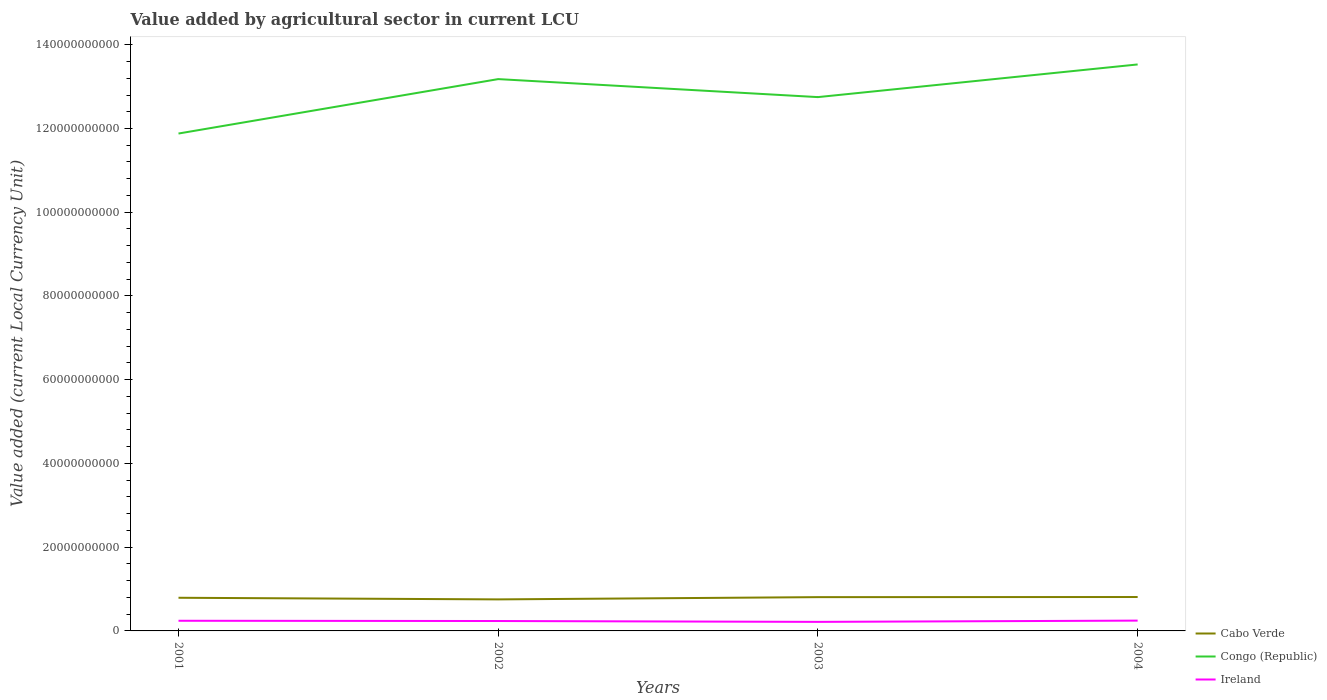How many different coloured lines are there?
Ensure brevity in your answer.  3. Is the number of lines equal to the number of legend labels?
Your answer should be very brief. Yes. Across all years, what is the maximum value added by agricultural sector in Ireland?
Offer a very short reply. 2.16e+09. What is the total value added by agricultural sector in Cabo Verde in the graph?
Your answer should be very brief. -2.96e+07. What is the difference between the highest and the second highest value added by agricultural sector in Cabo Verde?
Your response must be concise. 5.65e+08. What is the difference between the highest and the lowest value added by agricultural sector in Ireland?
Provide a short and direct response. 3. How many years are there in the graph?
Provide a succinct answer. 4. How many legend labels are there?
Offer a very short reply. 3. What is the title of the graph?
Keep it short and to the point. Value added by agricultural sector in current LCU. Does "Colombia" appear as one of the legend labels in the graph?
Offer a very short reply. No. What is the label or title of the X-axis?
Offer a very short reply. Years. What is the label or title of the Y-axis?
Your response must be concise. Value added (current Local Currency Unit). What is the Value added (current Local Currency Unit) of Cabo Verde in 2001?
Your response must be concise. 7.92e+09. What is the Value added (current Local Currency Unit) in Congo (Republic) in 2001?
Your answer should be compact. 1.19e+11. What is the Value added (current Local Currency Unit) in Ireland in 2001?
Keep it short and to the point. 2.43e+09. What is the Value added (current Local Currency Unit) in Cabo Verde in 2002?
Provide a short and direct response. 7.53e+09. What is the Value added (current Local Currency Unit) of Congo (Republic) in 2002?
Give a very brief answer. 1.32e+11. What is the Value added (current Local Currency Unit) in Ireland in 2002?
Give a very brief answer. 2.37e+09. What is the Value added (current Local Currency Unit) of Cabo Verde in 2003?
Provide a succinct answer. 8.07e+09. What is the Value added (current Local Currency Unit) in Congo (Republic) in 2003?
Give a very brief answer. 1.28e+11. What is the Value added (current Local Currency Unit) of Ireland in 2003?
Offer a terse response. 2.16e+09. What is the Value added (current Local Currency Unit) of Cabo Verde in 2004?
Keep it short and to the point. 8.10e+09. What is the Value added (current Local Currency Unit) of Congo (Republic) in 2004?
Make the answer very short. 1.35e+11. What is the Value added (current Local Currency Unit) of Ireland in 2004?
Ensure brevity in your answer.  2.46e+09. Across all years, what is the maximum Value added (current Local Currency Unit) of Cabo Verde?
Your response must be concise. 8.10e+09. Across all years, what is the maximum Value added (current Local Currency Unit) in Congo (Republic)?
Provide a succinct answer. 1.35e+11. Across all years, what is the maximum Value added (current Local Currency Unit) in Ireland?
Provide a short and direct response. 2.46e+09. Across all years, what is the minimum Value added (current Local Currency Unit) of Cabo Verde?
Make the answer very short. 7.53e+09. Across all years, what is the minimum Value added (current Local Currency Unit) of Congo (Republic)?
Your response must be concise. 1.19e+11. Across all years, what is the minimum Value added (current Local Currency Unit) of Ireland?
Offer a terse response. 2.16e+09. What is the total Value added (current Local Currency Unit) in Cabo Verde in the graph?
Ensure brevity in your answer.  3.16e+1. What is the total Value added (current Local Currency Unit) in Congo (Republic) in the graph?
Give a very brief answer. 5.13e+11. What is the total Value added (current Local Currency Unit) in Ireland in the graph?
Offer a very short reply. 9.42e+09. What is the difference between the Value added (current Local Currency Unit) in Cabo Verde in 2001 and that in 2002?
Give a very brief answer. 3.89e+08. What is the difference between the Value added (current Local Currency Unit) in Congo (Republic) in 2001 and that in 2002?
Keep it short and to the point. -1.30e+1. What is the difference between the Value added (current Local Currency Unit) in Ireland in 2001 and that in 2002?
Ensure brevity in your answer.  6.06e+07. What is the difference between the Value added (current Local Currency Unit) in Cabo Verde in 2001 and that in 2003?
Ensure brevity in your answer.  -1.47e+08. What is the difference between the Value added (current Local Currency Unit) in Congo (Republic) in 2001 and that in 2003?
Give a very brief answer. -8.70e+09. What is the difference between the Value added (current Local Currency Unit) in Ireland in 2001 and that in 2003?
Your answer should be very brief. 2.67e+08. What is the difference between the Value added (current Local Currency Unit) of Cabo Verde in 2001 and that in 2004?
Offer a very short reply. -1.76e+08. What is the difference between the Value added (current Local Currency Unit) in Congo (Republic) in 2001 and that in 2004?
Your response must be concise. -1.65e+1. What is the difference between the Value added (current Local Currency Unit) in Ireland in 2001 and that in 2004?
Make the answer very short. -3.66e+07. What is the difference between the Value added (current Local Currency Unit) in Cabo Verde in 2002 and that in 2003?
Offer a very short reply. -5.35e+08. What is the difference between the Value added (current Local Currency Unit) of Congo (Republic) in 2002 and that in 2003?
Your response must be concise. 4.30e+09. What is the difference between the Value added (current Local Currency Unit) of Ireland in 2002 and that in 2003?
Ensure brevity in your answer.  2.06e+08. What is the difference between the Value added (current Local Currency Unit) in Cabo Verde in 2002 and that in 2004?
Provide a succinct answer. -5.65e+08. What is the difference between the Value added (current Local Currency Unit) of Congo (Republic) in 2002 and that in 2004?
Your answer should be compact. -3.50e+09. What is the difference between the Value added (current Local Currency Unit) of Ireland in 2002 and that in 2004?
Offer a very short reply. -9.72e+07. What is the difference between the Value added (current Local Currency Unit) of Cabo Verde in 2003 and that in 2004?
Provide a short and direct response. -2.96e+07. What is the difference between the Value added (current Local Currency Unit) in Congo (Republic) in 2003 and that in 2004?
Your answer should be compact. -7.80e+09. What is the difference between the Value added (current Local Currency Unit) in Ireland in 2003 and that in 2004?
Your answer should be very brief. -3.03e+08. What is the difference between the Value added (current Local Currency Unit) in Cabo Verde in 2001 and the Value added (current Local Currency Unit) in Congo (Republic) in 2002?
Offer a terse response. -1.24e+11. What is the difference between the Value added (current Local Currency Unit) in Cabo Verde in 2001 and the Value added (current Local Currency Unit) in Ireland in 2002?
Your answer should be very brief. 5.55e+09. What is the difference between the Value added (current Local Currency Unit) in Congo (Republic) in 2001 and the Value added (current Local Currency Unit) in Ireland in 2002?
Your answer should be very brief. 1.16e+11. What is the difference between the Value added (current Local Currency Unit) of Cabo Verde in 2001 and the Value added (current Local Currency Unit) of Congo (Republic) in 2003?
Your response must be concise. -1.20e+11. What is the difference between the Value added (current Local Currency Unit) in Cabo Verde in 2001 and the Value added (current Local Currency Unit) in Ireland in 2003?
Your answer should be very brief. 5.76e+09. What is the difference between the Value added (current Local Currency Unit) in Congo (Republic) in 2001 and the Value added (current Local Currency Unit) in Ireland in 2003?
Offer a very short reply. 1.17e+11. What is the difference between the Value added (current Local Currency Unit) of Cabo Verde in 2001 and the Value added (current Local Currency Unit) of Congo (Republic) in 2004?
Your answer should be very brief. -1.27e+11. What is the difference between the Value added (current Local Currency Unit) in Cabo Verde in 2001 and the Value added (current Local Currency Unit) in Ireland in 2004?
Offer a very short reply. 5.46e+09. What is the difference between the Value added (current Local Currency Unit) of Congo (Republic) in 2001 and the Value added (current Local Currency Unit) of Ireland in 2004?
Your answer should be very brief. 1.16e+11. What is the difference between the Value added (current Local Currency Unit) in Cabo Verde in 2002 and the Value added (current Local Currency Unit) in Congo (Republic) in 2003?
Offer a very short reply. -1.20e+11. What is the difference between the Value added (current Local Currency Unit) in Cabo Verde in 2002 and the Value added (current Local Currency Unit) in Ireland in 2003?
Provide a short and direct response. 5.37e+09. What is the difference between the Value added (current Local Currency Unit) in Congo (Republic) in 2002 and the Value added (current Local Currency Unit) in Ireland in 2003?
Make the answer very short. 1.30e+11. What is the difference between the Value added (current Local Currency Unit) in Cabo Verde in 2002 and the Value added (current Local Currency Unit) in Congo (Republic) in 2004?
Make the answer very short. -1.28e+11. What is the difference between the Value added (current Local Currency Unit) in Cabo Verde in 2002 and the Value added (current Local Currency Unit) in Ireland in 2004?
Your answer should be very brief. 5.07e+09. What is the difference between the Value added (current Local Currency Unit) in Congo (Republic) in 2002 and the Value added (current Local Currency Unit) in Ireland in 2004?
Provide a succinct answer. 1.29e+11. What is the difference between the Value added (current Local Currency Unit) of Cabo Verde in 2003 and the Value added (current Local Currency Unit) of Congo (Republic) in 2004?
Keep it short and to the point. -1.27e+11. What is the difference between the Value added (current Local Currency Unit) of Cabo Verde in 2003 and the Value added (current Local Currency Unit) of Ireland in 2004?
Provide a short and direct response. 5.60e+09. What is the difference between the Value added (current Local Currency Unit) of Congo (Republic) in 2003 and the Value added (current Local Currency Unit) of Ireland in 2004?
Your answer should be very brief. 1.25e+11. What is the average Value added (current Local Currency Unit) of Cabo Verde per year?
Ensure brevity in your answer.  7.90e+09. What is the average Value added (current Local Currency Unit) in Congo (Republic) per year?
Your answer should be compact. 1.28e+11. What is the average Value added (current Local Currency Unit) in Ireland per year?
Your answer should be compact. 2.35e+09. In the year 2001, what is the difference between the Value added (current Local Currency Unit) in Cabo Verde and Value added (current Local Currency Unit) in Congo (Republic)?
Provide a succinct answer. -1.11e+11. In the year 2001, what is the difference between the Value added (current Local Currency Unit) of Cabo Verde and Value added (current Local Currency Unit) of Ireland?
Make the answer very short. 5.49e+09. In the year 2001, what is the difference between the Value added (current Local Currency Unit) in Congo (Republic) and Value added (current Local Currency Unit) in Ireland?
Your response must be concise. 1.16e+11. In the year 2002, what is the difference between the Value added (current Local Currency Unit) in Cabo Verde and Value added (current Local Currency Unit) in Congo (Republic)?
Keep it short and to the point. -1.24e+11. In the year 2002, what is the difference between the Value added (current Local Currency Unit) of Cabo Verde and Value added (current Local Currency Unit) of Ireland?
Ensure brevity in your answer.  5.17e+09. In the year 2002, what is the difference between the Value added (current Local Currency Unit) of Congo (Republic) and Value added (current Local Currency Unit) of Ireland?
Provide a short and direct response. 1.29e+11. In the year 2003, what is the difference between the Value added (current Local Currency Unit) in Cabo Verde and Value added (current Local Currency Unit) in Congo (Republic)?
Keep it short and to the point. -1.19e+11. In the year 2003, what is the difference between the Value added (current Local Currency Unit) of Cabo Verde and Value added (current Local Currency Unit) of Ireland?
Provide a short and direct response. 5.91e+09. In the year 2003, what is the difference between the Value added (current Local Currency Unit) of Congo (Republic) and Value added (current Local Currency Unit) of Ireland?
Make the answer very short. 1.25e+11. In the year 2004, what is the difference between the Value added (current Local Currency Unit) of Cabo Verde and Value added (current Local Currency Unit) of Congo (Republic)?
Your response must be concise. -1.27e+11. In the year 2004, what is the difference between the Value added (current Local Currency Unit) in Cabo Verde and Value added (current Local Currency Unit) in Ireland?
Make the answer very short. 5.63e+09. In the year 2004, what is the difference between the Value added (current Local Currency Unit) of Congo (Republic) and Value added (current Local Currency Unit) of Ireland?
Ensure brevity in your answer.  1.33e+11. What is the ratio of the Value added (current Local Currency Unit) of Cabo Verde in 2001 to that in 2002?
Provide a succinct answer. 1.05. What is the ratio of the Value added (current Local Currency Unit) in Congo (Republic) in 2001 to that in 2002?
Your answer should be very brief. 0.9. What is the ratio of the Value added (current Local Currency Unit) in Ireland in 2001 to that in 2002?
Offer a terse response. 1.03. What is the ratio of the Value added (current Local Currency Unit) of Cabo Verde in 2001 to that in 2003?
Provide a short and direct response. 0.98. What is the ratio of the Value added (current Local Currency Unit) in Congo (Republic) in 2001 to that in 2003?
Keep it short and to the point. 0.93. What is the ratio of the Value added (current Local Currency Unit) in Ireland in 2001 to that in 2003?
Your response must be concise. 1.12. What is the ratio of the Value added (current Local Currency Unit) in Cabo Verde in 2001 to that in 2004?
Keep it short and to the point. 0.98. What is the ratio of the Value added (current Local Currency Unit) in Congo (Republic) in 2001 to that in 2004?
Ensure brevity in your answer.  0.88. What is the ratio of the Value added (current Local Currency Unit) in Ireland in 2001 to that in 2004?
Keep it short and to the point. 0.99. What is the ratio of the Value added (current Local Currency Unit) in Cabo Verde in 2002 to that in 2003?
Provide a succinct answer. 0.93. What is the ratio of the Value added (current Local Currency Unit) in Congo (Republic) in 2002 to that in 2003?
Your response must be concise. 1.03. What is the ratio of the Value added (current Local Currency Unit) of Ireland in 2002 to that in 2003?
Keep it short and to the point. 1.1. What is the ratio of the Value added (current Local Currency Unit) of Cabo Verde in 2002 to that in 2004?
Offer a terse response. 0.93. What is the ratio of the Value added (current Local Currency Unit) in Congo (Republic) in 2002 to that in 2004?
Make the answer very short. 0.97. What is the ratio of the Value added (current Local Currency Unit) in Ireland in 2002 to that in 2004?
Your answer should be very brief. 0.96. What is the ratio of the Value added (current Local Currency Unit) in Congo (Republic) in 2003 to that in 2004?
Give a very brief answer. 0.94. What is the ratio of the Value added (current Local Currency Unit) in Ireland in 2003 to that in 2004?
Offer a very short reply. 0.88. What is the difference between the highest and the second highest Value added (current Local Currency Unit) of Cabo Verde?
Offer a terse response. 2.96e+07. What is the difference between the highest and the second highest Value added (current Local Currency Unit) in Congo (Republic)?
Provide a succinct answer. 3.50e+09. What is the difference between the highest and the second highest Value added (current Local Currency Unit) in Ireland?
Ensure brevity in your answer.  3.66e+07. What is the difference between the highest and the lowest Value added (current Local Currency Unit) in Cabo Verde?
Your answer should be very brief. 5.65e+08. What is the difference between the highest and the lowest Value added (current Local Currency Unit) of Congo (Republic)?
Your answer should be compact. 1.65e+1. What is the difference between the highest and the lowest Value added (current Local Currency Unit) of Ireland?
Offer a very short reply. 3.03e+08. 